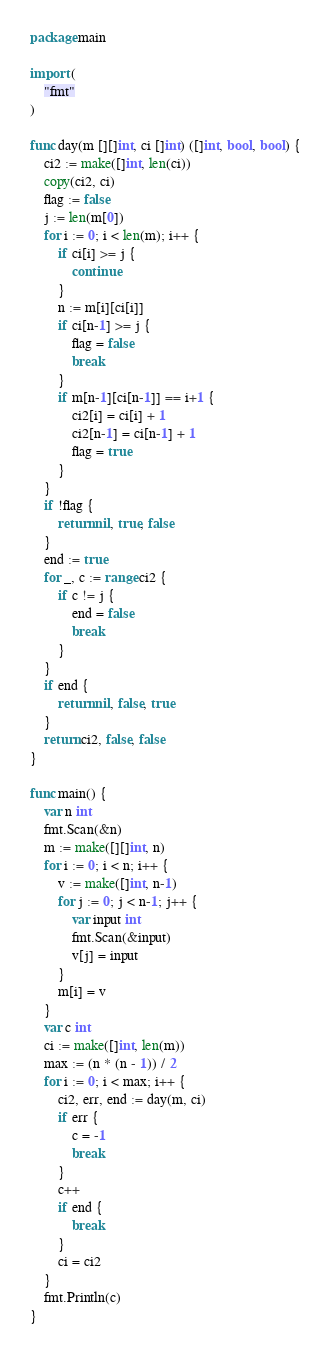Convert code to text. <code><loc_0><loc_0><loc_500><loc_500><_Go_>package main

import (
	"fmt"
)

func day(m [][]int, ci []int) ([]int, bool, bool) {
	ci2 := make([]int, len(ci))
	copy(ci2, ci)
	flag := false
	j := len(m[0])
	for i := 0; i < len(m); i++ {
		if ci[i] >= j {
			continue
		}
		n := m[i][ci[i]]
		if ci[n-1] >= j {
			flag = false
			break
		}
		if m[n-1][ci[n-1]] == i+1 {
			ci2[i] = ci[i] + 1
			ci2[n-1] = ci[n-1] + 1
			flag = true
		}
	}
	if !flag {
		return nil, true, false
	}
	end := true
	for _, c := range ci2 {
		if c != j {
			end = false
			break
		}
	}
	if end {
		return nil, false, true
	}
	return ci2, false, false
}

func main() {
	var n int
	fmt.Scan(&n)
	m := make([][]int, n)
	for i := 0; i < n; i++ {
		v := make([]int, n-1)
		for j := 0; j < n-1; j++ {
			var input int
			fmt.Scan(&input)
			v[j] = input
		}
		m[i] = v
	}
	var c int
	ci := make([]int, len(m))
	max := (n * (n - 1)) / 2
	for i := 0; i < max; i++ {
		ci2, err, end := day(m, ci)
		if err {
			c = -1
			break
		}
		c++
		if end {
			break
		}
		ci = ci2
	}
	fmt.Println(c)
}
</code> 